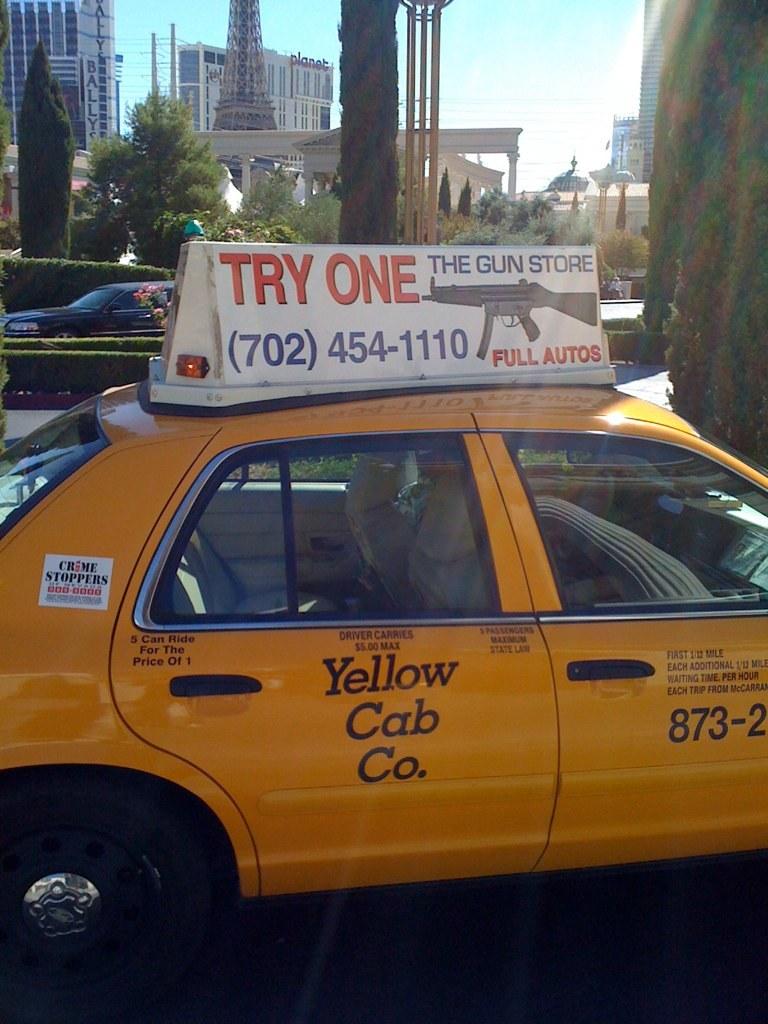What does the store sell?
Make the answer very short. Guns. What is the gun store's number?
Keep it short and to the point. 702-454-1110. 